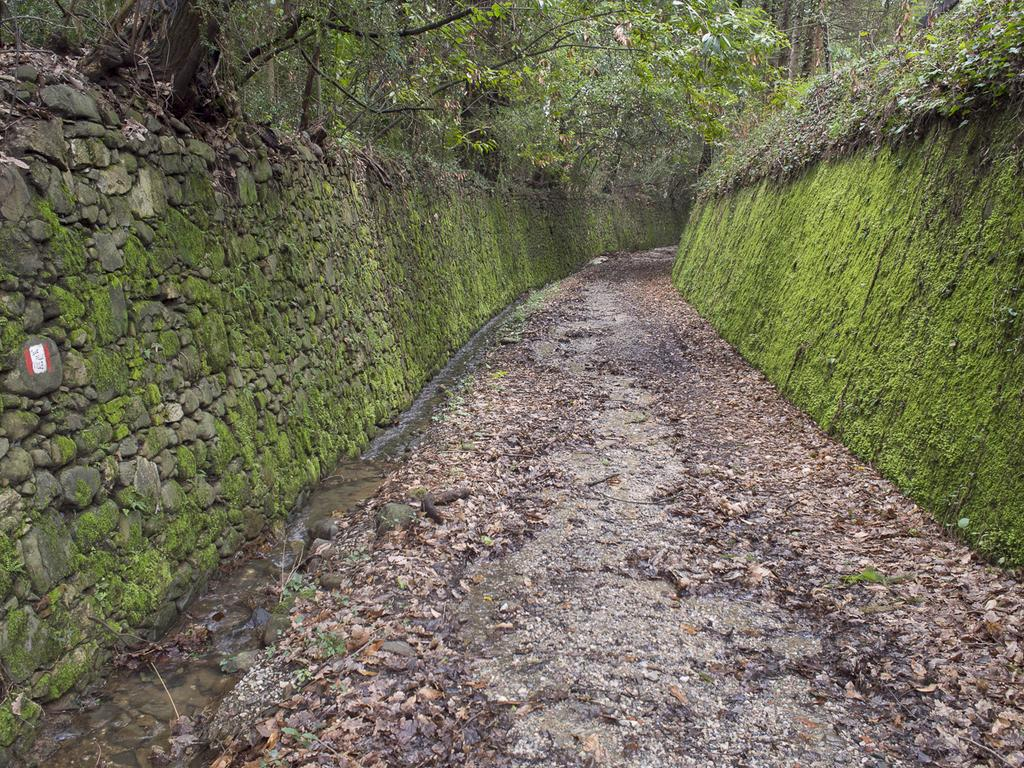What type of vegetation can be seen in the image? There are trees and plants in the image. What is the condition of the ground in the image? Dried leaves are present in the image. What is the source of water visible in the image? There is a small canal with a root in the image. What statement can be seen written on the fog in the image? There is no fog present in the image, and therefore no statement can be seen written on it. 